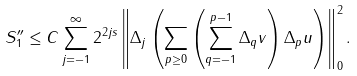Convert formula to latex. <formula><loc_0><loc_0><loc_500><loc_500>S _ { 1 } ^ { \prime \prime } \leq C \sum _ { j = - 1 } ^ { \infty } 2 ^ { 2 j s } \left \| \Delta _ { j } \left ( \sum _ { p \geq 0 } \left ( \sum _ { q = - 1 } ^ { p - 1 } \Delta _ { q } v \right ) \Delta _ { p } u \right ) \right \| _ { 0 } ^ { 2 } .</formula> 